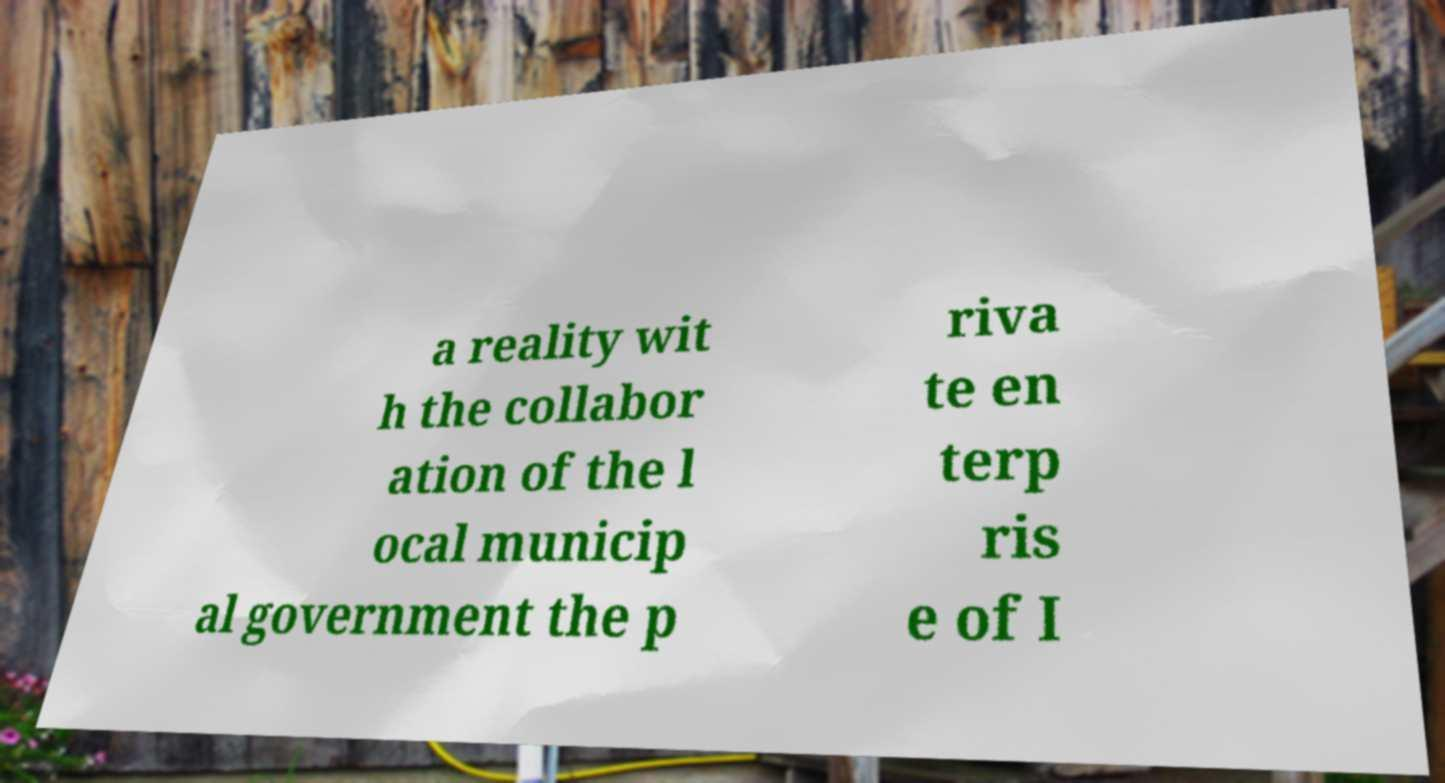Please identify and transcribe the text found in this image. a reality wit h the collabor ation of the l ocal municip al government the p riva te en terp ris e of I 